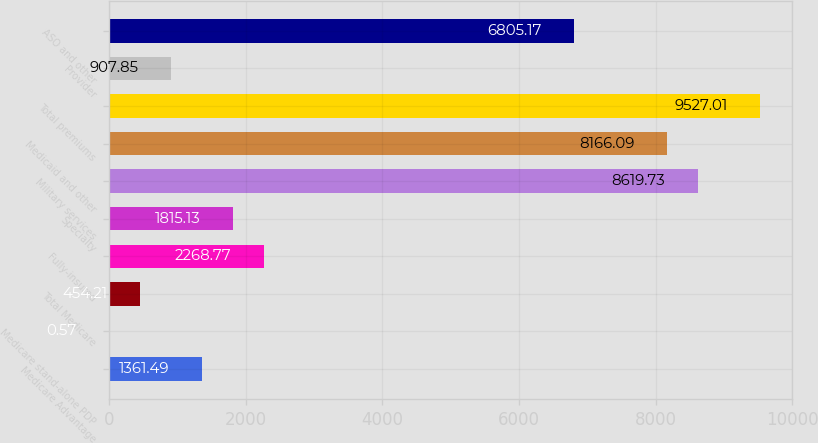<chart> <loc_0><loc_0><loc_500><loc_500><bar_chart><fcel>Medicare Advantage<fcel>Medicare stand-alone PDP<fcel>Total Medicare<fcel>Fully-insured<fcel>Specialty<fcel>Military services<fcel>Medicaid and other<fcel>Total premiums<fcel>Provider<fcel>ASO and other<nl><fcel>1361.49<fcel>0.57<fcel>454.21<fcel>2268.77<fcel>1815.13<fcel>8619.73<fcel>8166.09<fcel>9527.01<fcel>907.85<fcel>6805.17<nl></chart> 